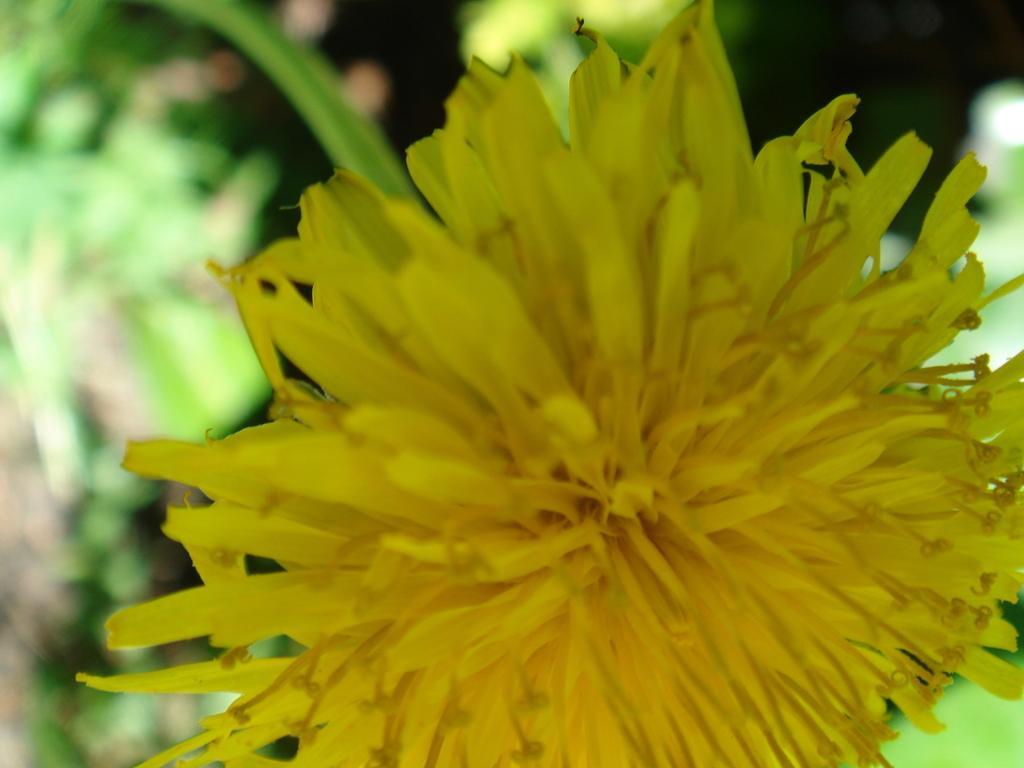Can you describe this image briefly? In the foreground of the image there is a flower. the background of the image is blur. 